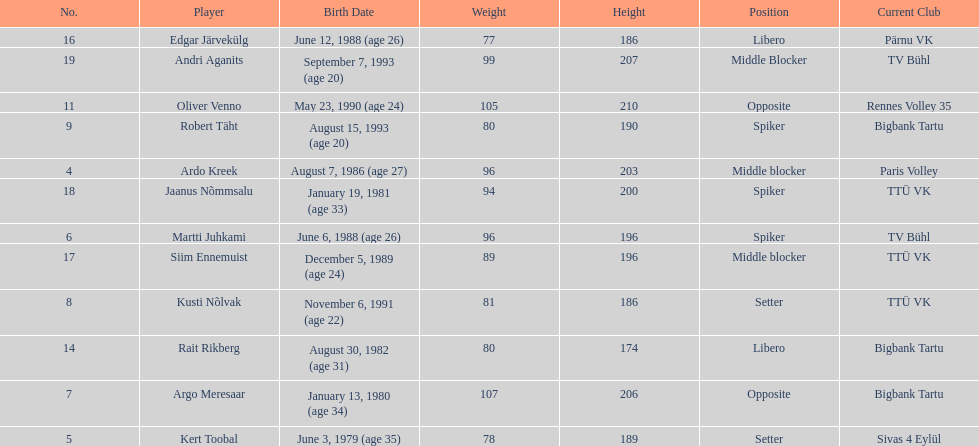Who is the tallest member of estonia's men's national volleyball team? Oliver Venno. 